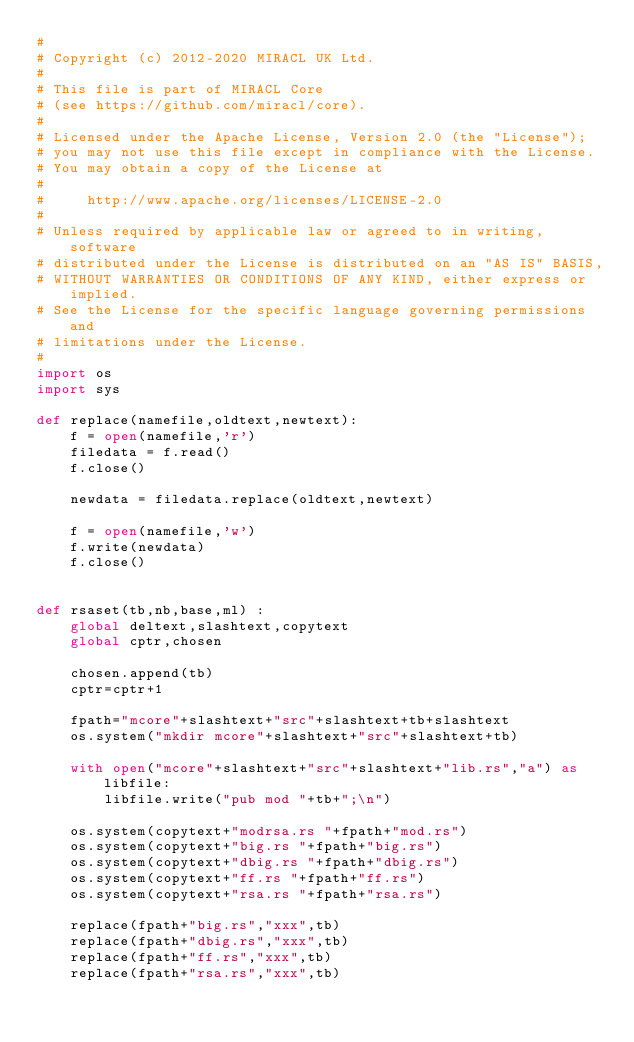Convert code to text. <code><loc_0><loc_0><loc_500><loc_500><_Python_>#
# Copyright (c) 2012-2020 MIRACL UK Ltd.
#
# This file is part of MIRACL Core
# (see https://github.com/miracl/core).
#
# Licensed under the Apache License, Version 2.0 (the "License");
# you may not use this file except in compliance with the License.
# You may obtain a copy of the License at
#
#     http://www.apache.org/licenses/LICENSE-2.0
#
# Unless required by applicable law or agreed to in writing, software
# distributed under the License is distributed on an "AS IS" BASIS,
# WITHOUT WARRANTIES OR CONDITIONS OF ANY KIND, either express or implied.
# See the License for the specific language governing permissions and
# limitations under the License.
#
import os
import sys

def replace(namefile,oldtext,newtext):
    f = open(namefile,'r')
    filedata = f.read()
    f.close()

    newdata = filedata.replace(oldtext,newtext)

    f = open(namefile,'w')
    f.write(newdata)
    f.close()


def rsaset(tb,nb,base,ml) :
    global deltext,slashtext,copytext
    global cptr,chosen

    chosen.append(tb)
    cptr=cptr+1

    fpath="mcore"+slashtext+"src"+slashtext+tb+slashtext
    os.system("mkdir mcore"+slashtext+"src"+slashtext+tb)

    with open("mcore"+slashtext+"src"+slashtext+"lib.rs","a") as libfile:
        libfile.write("pub mod "+tb+";\n")

    os.system(copytext+"modrsa.rs "+fpath+"mod.rs")
    os.system(copytext+"big.rs "+fpath+"big.rs")
    os.system(copytext+"dbig.rs "+fpath+"dbig.rs")
    os.system(copytext+"ff.rs "+fpath+"ff.rs")
    os.system(copytext+"rsa.rs "+fpath+"rsa.rs")

    replace(fpath+"big.rs","xxx",tb)
    replace(fpath+"dbig.rs","xxx",tb)
    replace(fpath+"ff.rs","xxx",tb)
    replace(fpath+"rsa.rs","xxx",tb)
</code> 